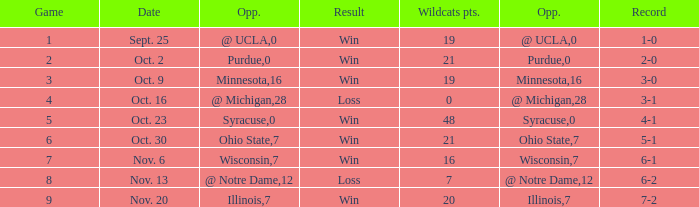How many wins or losses were there when the record was 3-0? 1.0. 